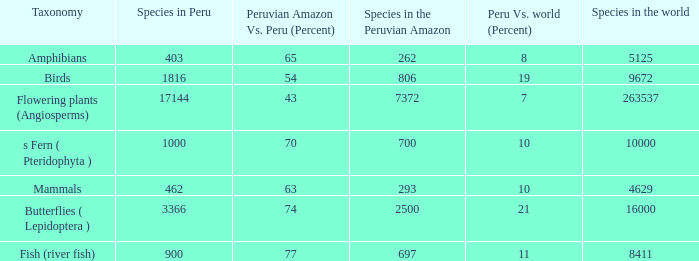Could you parse the entire table as a dict? {'header': ['Taxonomy', 'Species in Peru', 'Peruvian Amazon Vs. Peru (Percent)', 'Species in the Peruvian Amazon', 'Peru Vs. world (Percent)', 'Species in the world'], 'rows': [['Amphibians', '403', '65', '262', '8', '5125'], ['Birds', '1816', '54', '806', '19', '9672'], ['Flowering plants (Angiosperms)', '17144', '43', '7372', '7', '263537'], ['s Fern ( Pteridophyta )', '1000', '70', '700', '10', '10000'], ['Mammals', '462', '63', '293', '10', '4629'], ['Butterflies ( Lepidoptera )', '3366', '74', '2500', '21', '16000'], ['Fish (river fish)', '900', '77', '697', '11', '8411']]} What's the maximum peru vs. world (percent) with 9672 species in the world  19.0. 